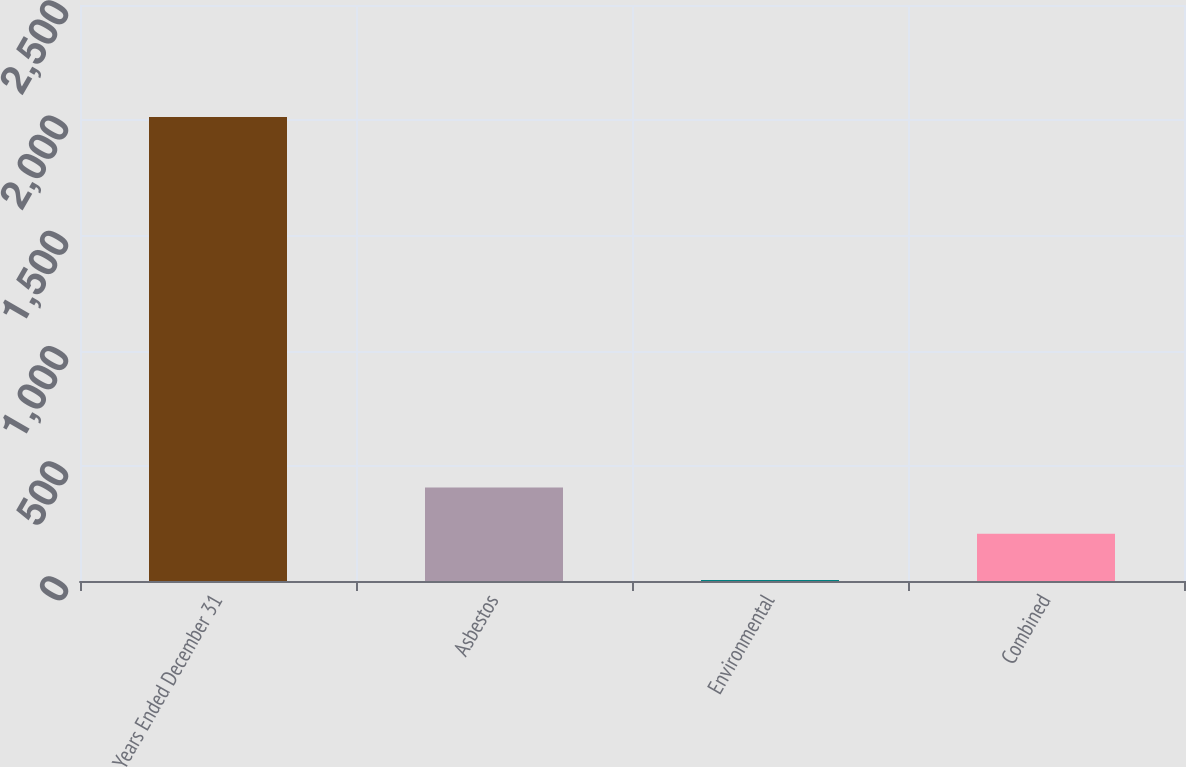<chart> <loc_0><loc_0><loc_500><loc_500><bar_chart><fcel>Years Ended December 31<fcel>Asbestos<fcel>Environmental<fcel>Combined<nl><fcel>2014<fcel>406.24<fcel>4.3<fcel>205.27<nl></chart> 